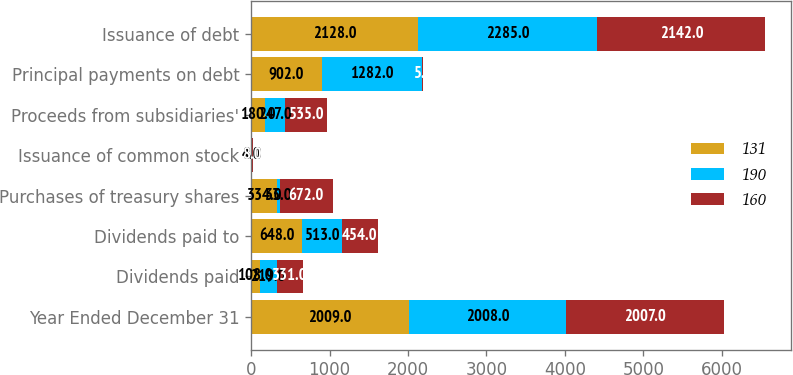Convert chart. <chart><loc_0><loc_0><loc_500><loc_500><stacked_bar_chart><ecel><fcel>Year Ended December 31<fcel>Dividends paid<fcel>Dividends paid to<fcel>Purchases of treasury shares<fcel>Issuance of common stock<fcel>Proceeds from subsidiaries'<fcel>Principal payments on debt<fcel>Issuance of debt<nl><fcel>131<fcel>2009<fcel>108<fcel>648<fcel>334<fcel>8<fcel>180<fcel>902<fcel>2128<nl><fcel>190<fcel>2008<fcel>219<fcel>513<fcel>33<fcel>4<fcel>247<fcel>1282<fcel>2285<nl><fcel>160<fcel>2007<fcel>331<fcel>454<fcel>672<fcel>8<fcel>535<fcel>5<fcel>2142<nl></chart> 